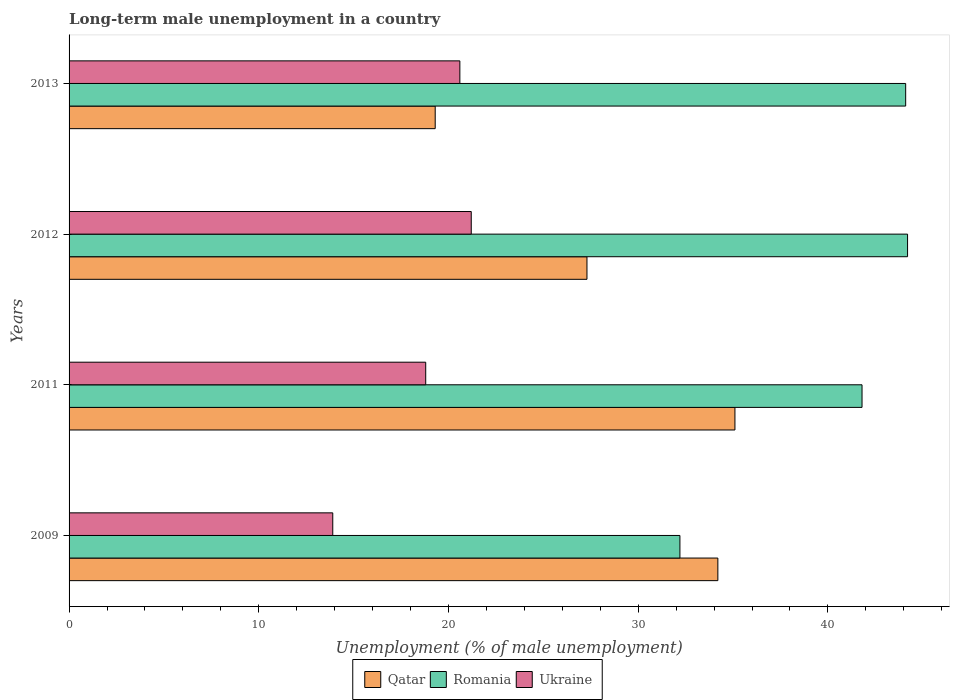How many different coloured bars are there?
Your answer should be very brief. 3. How many bars are there on the 1st tick from the top?
Your response must be concise. 3. What is the label of the 3rd group of bars from the top?
Your answer should be compact. 2011. What is the percentage of long-term unemployed male population in Qatar in 2011?
Offer a very short reply. 35.1. Across all years, what is the maximum percentage of long-term unemployed male population in Romania?
Offer a terse response. 44.2. Across all years, what is the minimum percentage of long-term unemployed male population in Romania?
Your answer should be compact. 32.2. In which year was the percentage of long-term unemployed male population in Qatar maximum?
Give a very brief answer. 2011. In which year was the percentage of long-term unemployed male population in Ukraine minimum?
Keep it short and to the point. 2009. What is the total percentage of long-term unemployed male population in Ukraine in the graph?
Your answer should be compact. 74.5. What is the difference between the percentage of long-term unemployed male population in Romania in 2009 and that in 2012?
Provide a succinct answer. -12. What is the difference between the percentage of long-term unemployed male population in Ukraine in 2011 and the percentage of long-term unemployed male population in Romania in 2012?
Provide a succinct answer. -25.4. What is the average percentage of long-term unemployed male population in Qatar per year?
Provide a short and direct response. 28.97. In the year 2011, what is the difference between the percentage of long-term unemployed male population in Ukraine and percentage of long-term unemployed male population in Qatar?
Make the answer very short. -16.3. What is the ratio of the percentage of long-term unemployed male population in Ukraine in 2009 to that in 2012?
Offer a very short reply. 0.66. What is the difference between the highest and the second highest percentage of long-term unemployed male population in Qatar?
Keep it short and to the point. 0.9. What is the difference between the highest and the lowest percentage of long-term unemployed male population in Qatar?
Offer a terse response. 15.8. In how many years, is the percentage of long-term unemployed male population in Romania greater than the average percentage of long-term unemployed male population in Romania taken over all years?
Keep it short and to the point. 3. What does the 1st bar from the top in 2011 represents?
Keep it short and to the point. Ukraine. What does the 1st bar from the bottom in 2009 represents?
Offer a terse response. Qatar. Is it the case that in every year, the sum of the percentage of long-term unemployed male population in Romania and percentage of long-term unemployed male population in Ukraine is greater than the percentage of long-term unemployed male population in Qatar?
Keep it short and to the point. Yes. What is the difference between two consecutive major ticks on the X-axis?
Your answer should be very brief. 10. Does the graph contain any zero values?
Offer a terse response. No. Where does the legend appear in the graph?
Keep it short and to the point. Bottom center. How are the legend labels stacked?
Offer a terse response. Horizontal. What is the title of the graph?
Your answer should be compact. Long-term male unemployment in a country. What is the label or title of the X-axis?
Provide a short and direct response. Unemployment (% of male unemployment). What is the Unemployment (% of male unemployment) of Qatar in 2009?
Offer a terse response. 34.2. What is the Unemployment (% of male unemployment) in Romania in 2009?
Your answer should be compact. 32.2. What is the Unemployment (% of male unemployment) of Ukraine in 2009?
Make the answer very short. 13.9. What is the Unemployment (% of male unemployment) in Qatar in 2011?
Offer a terse response. 35.1. What is the Unemployment (% of male unemployment) in Romania in 2011?
Ensure brevity in your answer.  41.8. What is the Unemployment (% of male unemployment) of Ukraine in 2011?
Your response must be concise. 18.8. What is the Unemployment (% of male unemployment) of Qatar in 2012?
Provide a short and direct response. 27.3. What is the Unemployment (% of male unemployment) of Romania in 2012?
Provide a short and direct response. 44.2. What is the Unemployment (% of male unemployment) of Ukraine in 2012?
Offer a terse response. 21.2. What is the Unemployment (% of male unemployment) of Qatar in 2013?
Your answer should be compact. 19.3. What is the Unemployment (% of male unemployment) in Romania in 2013?
Your answer should be very brief. 44.1. What is the Unemployment (% of male unemployment) of Ukraine in 2013?
Your answer should be compact. 20.6. Across all years, what is the maximum Unemployment (% of male unemployment) in Qatar?
Offer a very short reply. 35.1. Across all years, what is the maximum Unemployment (% of male unemployment) in Romania?
Keep it short and to the point. 44.2. Across all years, what is the maximum Unemployment (% of male unemployment) in Ukraine?
Your answer should be very brief. 21.2. Across all years, what is the minimum Unemployment (% of male unemployment) of Qatar?
Provide a succinct answer. 19.3. Across all years, what is the minimum Unemployment (% of male unemployment) of Romania?
Your answer should be compact. 32.2. Across all years, what is the minimum Unemployment (% of male unemployment) in Ukraine?
Provide a succinct answer. 13.9. What is the total Unemployment (% of male unemployment) in Qatar in the graph?
Your answer should be compact. 115.9. What is the total Unemployment (% of male unemployment) of Romania in the graph?
Make the answer very short. 162.3. What is the total Unemployment (% of male unemployment) of Ukraine in the graph?
Give a very brief answer. 74.5. What is the difference between the Unemployment (% of male unemployment) of Romania in 2009 and that in 2011?
Ensure brevity in your answer.  -9.6. What is the difference between the Unemployment (% of male unemployment) in Qatar in 2009 and that in 2012?
Keep it short and to the point. 6.9. What is the difference between the Unemployment (% of male unemployment) of Romania in 2009 and that in 2012?
Ensure brevity in your answer.  -12. What is the difference between the Unemployment (% of male unemployment) in Ukraine in 2009 and that in 2012?
Provide a short and direct response. -7.3. What is the difference between the Unemployment (% of male unemployment) of Romania in 2009 and that in 2013?
Ensure brevity in your answer.  -11.9. What is the difference between the Unemployment (% of male unemployment) of Qatar in 2011 and that in 2012?
Your answer should be compact. 7.8. What is the difference between the Unemployment (% of male unemployment) of Romania in 2011 and that in 2012?
Ensure brevity in your answer.  -2.4. What is the difference between the Unemployment (% of male unemployment) of Ukraine in 2011 and that in 2012?
Make the answer very short. -2.4. What is the difference between the Unemployment (% of male unemployment) in Ukraine in 2012 and that in 2013?
Your answer should be very brief. 0.6. What is the difference between the Unemployment (% of male unemployment) of Qatar in 2009 and the Unemployment (% of male unemployment) of Ukraine in 2012?
Offer a very short reply. 13. What is the difference between the Unemployment (% of male unemployment) in Romania in 2009 and the Unemployment (% of male unemployment) in Ukraine in 2012?
Your answer should be compact. 11. What is the difference between the Unemployment (% of male unemployment) in Qatar in 2011 and the Unemployment (% of male unemployment) in Romania in 2012?
Keep it short and to the point. -9.1. What is the difference between the Unemployment (% of male unemployment) of Romania in 2011 and the Unemployment (% of male unemployment) of Ukraine in 2012?
Ensure brevity in your answer.  20.6. What is the difference between the Unemployment (% of male unemployment) in Qatar in 2011 and the Unemployment (% of male unemployment) in Romania in 2013?
Your response must be concise. -9. What is the difference between the Unemployment (% of male unemployment) of Qatar in 2011 and the Unemployment (% of male unemployment) of Ukraine in 2013?
Make the answer very short. 14.5. What is the difference between the Unemployment (% of male unemployment) of Romania in 2011 and the Unemployment (% of male unemployment) of Ukraine in 2013?
Keep it short and to the point. 21.2. What is the difference between the Unemployment (% of male unemployment) of Qatar in 2012 and the Unemployment (% of male unemployment) of Romania in 2013?
Make the answer very short. -16.8. What is the difference between the Unemployment (% of male unemployment) of Romania in 2012 and the Unemployment (% of male unemployment) of Ukraine in 2013?
Your answer should be compact. 23.6. What is the average Unemployment (% of male unemployment) in Qatar per year?
Make the answer very short. 28.98. What is the average Unemployment (% of male unemployment) in Romania per year?
Your answer should be compact. 40.58. What is the average Unemployment (% of male unemployment) of Ukraine per year?
Your response must be concise. 18.62. In the year 2009, what is the difference between the Unemployment (% of male unemployment) of Qatar and Unemployment (% of male unemployment) of Ukraine?
Give a very brief answer. 20.3. In the year 2009, what is the difference between the Unemployment (% of male unemployment) in Romania and Unemployment (% of male unemployment) in Ukraine?
Give a very brief answer. 18.3. In the year 2011, what is the difference between the Unemployment (% of male unemployment) of Qatar and Unemployment (% of male unemployment) of Romania?
Ensure brevity in your answer.  -6.7. In the year 2011, what is the difference between the Unemployment (% of male unemployment) in Qatar and Unemployment (% of male unemployment) in Ukraine?
Keep it short and to the point. 16.3. In the year 2012, what is the difference between the Unemployment (% of male unemployment) in Qatar and Unemployment (% of male unemployment) in Romania?
Provide a succinct answer. -16.9. In the year 2013, what is the difference between the Unemployment (% of male unemployment) of Qatar and Unemployment (% of male unemployment) of Romania?
Keep it short and to the point. -24.8. In the year 2013, what is the difference between the Unemployment (% of male unemployment) of Romania and Unemployment (% of male unemployment) of Ukraine?
Your answer should be compact. 23.5. What is the ratio of the Unemployment (% of male unemployment) in Qatar in 2009 to that in 2011?
Give a very brief answer. 0.97. What is the ratio of the Unemployment (% of male unemployment) in Romania in 2009 to that in 2011?
Keep it short and to the point. 0.77. What is the ratio of the Unemployment (% of male unemployment) of Ukraine in 2009 to that in 2011?
Provide a succinct answer. 0.74. What is the ratio of the Unemployment (% of male unemployment) of Qatar in 2009 to that in 2012?
Offer a very short reply. 1.25. What is the ratio of the Unemployment (% of male unemployment) in Romania in 2009 to that in 2012?
Keep it short and to the point. 0.73. What is the ratio of the Unemployment (% of male unemployment) of Ukraine in 2009 to that in 2012?
Provide a succinct answer. 0.66. What is the ratio of the Unemployment (% of male unemployment) of Qatar in 2009 to that in 2013?
Give a very brief answer. 1.77. What is the ratio of the Unemployment (% of male unemployment) in Romania in 2009 to that in 2013?
Make the answer very short. 0.73. What is the ratio of the Unemployment (% of male unemployment) in Ukraine in 2009 to that in 2013?
Offer a terse response. 0.67. What is the ratio of the Unemployment (% of male unemployment) of Romania in 2011 to that in 2012?
Keep it short and to the point. 0.95. What is the ratio of the Unemployment (% of male unemployment) of Ukraine in 2011 to that in 2012?
Offer a very short reply. 0.89. What is the ratio of the Unemployment (% of male unemployment) in Qatar in 2011 to that in 2013?
Your response must be concise. 1.82. What is the ratio of the Unemployment (% of male unemployment) of Romania in 2011 to that in 2013?
Keep it short and to the point. 0.95. What is the ratio of the Unemployment (% of male unemployment) in Ukraine in 2011 to that in 2013?
Ensure brevity in your answer.  0.91. What is the ratio of the Unemployment (% of male unemployment) of Qatar in 2012 to that in 2013?
Your answer should be compact. 1.41. What is the ratio of the Unemployment (% of male unemployment) in Romania in 2012 to that in 2013?
Make the answer very short. 1. What is the ratio of the Unemployment (% of male unemployment) of Ukraine in 2012 to that in 2013?
Your answer should be very brief. 1.03. What is the difference between the highest and the second highest Unemployment (% of male unemployment) in Qatar?
Your response must be concise. 0.9. What is the difference between the highest and the second highest Unemployment (% of male unemployment) in Romania?
Your answer should be compact. 0.1. What is the difference between the highest and the second highest Unemployment (% of male unemployment) in Ukraine?
Provide a short and direct response. 0.6. What is the difference between the highest and the lowest Unemployment (% of male unemployment) in Romania?
Keep it short and to the point. 12. 